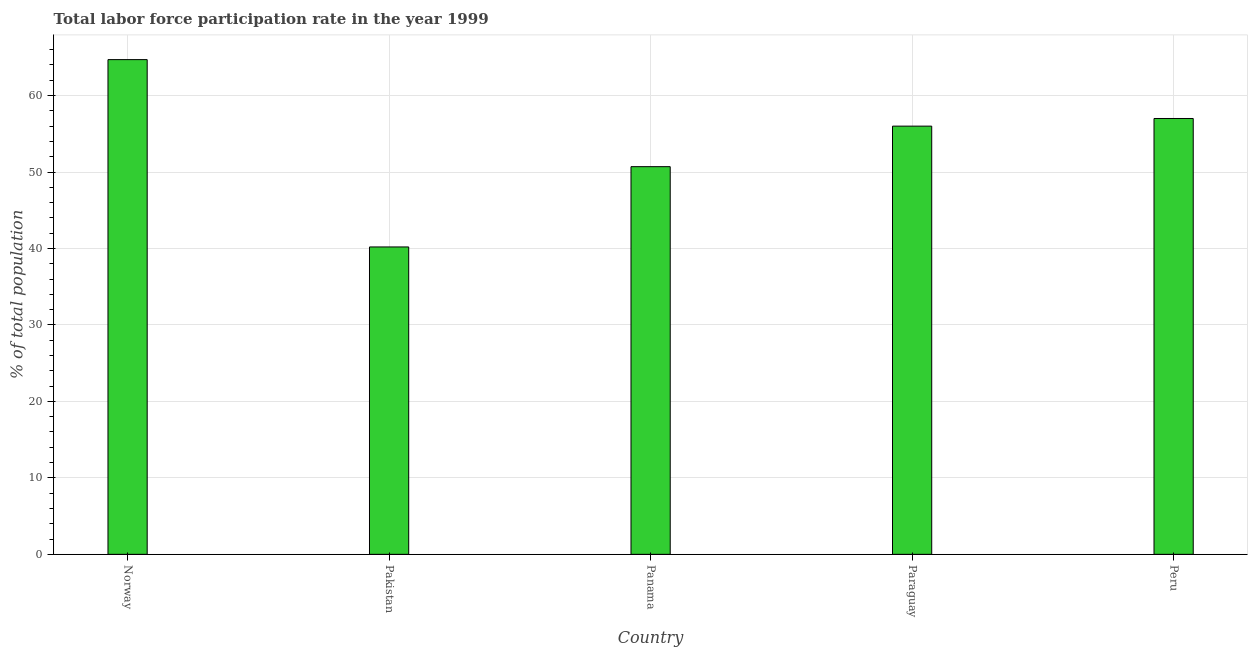Does the graph contain grids?
Ensure brevity in your answer.  Yes. What is the title of the graph?
Ensure brevity in your answer.  Total labor force participation rate in the year 1999. What is the label or title of the X-axis?
Make the answer very short. Country. What is the label or title of the Y-axis?
Your answer should be very brief. % of total population. Across all countries, what is the maximum total labor force participation rate?
Provide a succinct answer. 64.7. Across all countries, what is the minimum total labor force participation rate?
Provide a succinct answer. 40.2. In which country was the total labor force participation rate minimum?
Your answer should be compact. Pakistan. What is the sum of the total labor force participation rate?
Offer a terse response. 268.6. What is the difference between the total labor force participation rate in Norway and Pakistan?
Your response must be concise. 24.5. What is the average total labor force participation rate per country?
Offer a terse response. 53.72. What is the ratio of the total labor force participation rate in Pakistan to that in Peru?
Your answer should be very brief. 0.7. Is the total labor force participation rate in Norway less than that in Pakistan?
Your answer should be very brief. No. Is the difference between the total labor force participation rate in Pakistan and Panama greater than the difference between any two countries?
Provide a succinct answer. No. Is the sum of the total labor force participation rate in Norway and Pakistan greater than the maximum total labor force participation rate across all countries?
Offer a very short reply. Yes. How many bars are there?
Keep it short and to the point. 5. What is the difference between two consecutive major ticks on the Y-axis?
Your answer should be compact. 10. Are the values on the major ticks of Y-axis written in scientific E-notation?
Your response must be concise. No. What is the % of total population of Norway?
Your response must be concise. 64.7. What is the % of total population in Pakistan?
Your answer should be compact. 40.2. What is the % of total population in Panama?
Ensure brevity in your answer.  50.7. What is the % of total population in Paraguay?
Provide a succinct answer. 56. What is the difference between the % of total population in Norway and Paraguay?
Provide a short and direct response. 8.7. What is the difference between the % of total population in Norway and Peru?
Your answer should be very brief. 7.7. What is the difference between the % of total population in Pakistan and Panama?
Give a very brief answer. -10.5. What is the difference between the % of total population in Pakistan and Paraguay?
Ensure brevity in your answer.  -15.8. What is the difference between the % of total population in Pakistan and Peru?
Your answer should be compact. -16.8. What is the difference between the % of total population in Panama and Peru?
Offer a very short reply. -6.3. What is the difference between the % of total population in Paraguay and Peru?
Ensure brevity in your answer.  -1. What is the ratio of the % of total population in Norway to that in Pakistan?
Your answer should be compact. 1.61. What is the ratio of the % of total population in Norway to that in Panama?
Your answer should be compact. 1.28. What is the ratio of the % of total population in Norway to that in Paraguay?
Provide a short and direct response. 1.16. What is the ratio of the % of total population in Norway to that in Peru?
Make the answer very short. 1.14. What is the ratio of the % of total population in Pakistan to that in Panama?
Make the answer very short. 0.79. What is the ratio of the % of total population in Pakistan to that in Paraguay?
Keep it short and to the point. 0.72. What is the ratio of the % of total population in Pakistan to that in Peru?
Make the answer very short. 0.7. What is the ratio of the % of total population in Panama to that in Paraguay?
Make the answer very short. 0.91. What is the ratio of the % of total population in Panama to that in Peru?
Ensure brevity in your answer.  0.89. What is the ratio of the % of total population in Paraguay to that in Peru?
Offer a very short reply. 0.98. 